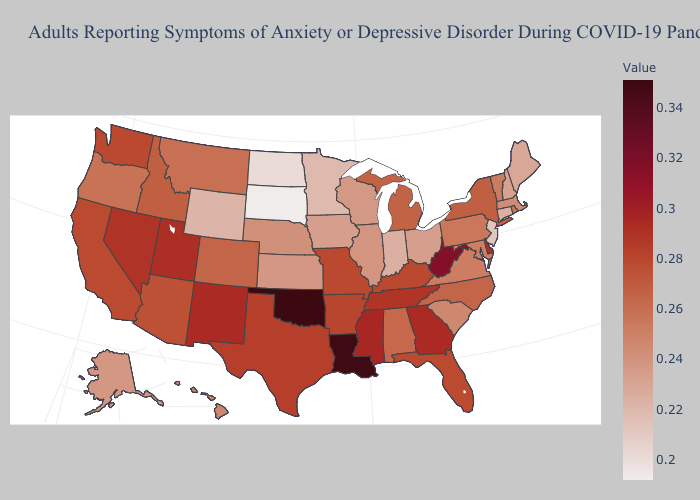Among the states that border Delaware , which have the highest value?
Short answer required. Pennsylvania. Does Oklahoma have the highest value in the USA?
Concise answer only. Yes. Does Vermont have a higher value than South Dakota?
Short answer required. Yes. Among the states that border Wyoming , does South Dakota have the lowest value?
Quick response, please. Yes. Among the states that border Utah , which have the highest value?
Write a very short answer. New Mexico. 